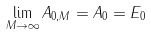Convert formula to latex. <formula><loc_0><loc_0><loc_500><loc_500>\lim _ { M \rightarrow \infty } A _ { 0 , M } = A _ { 0 } = E _ { 0 }</formula> 